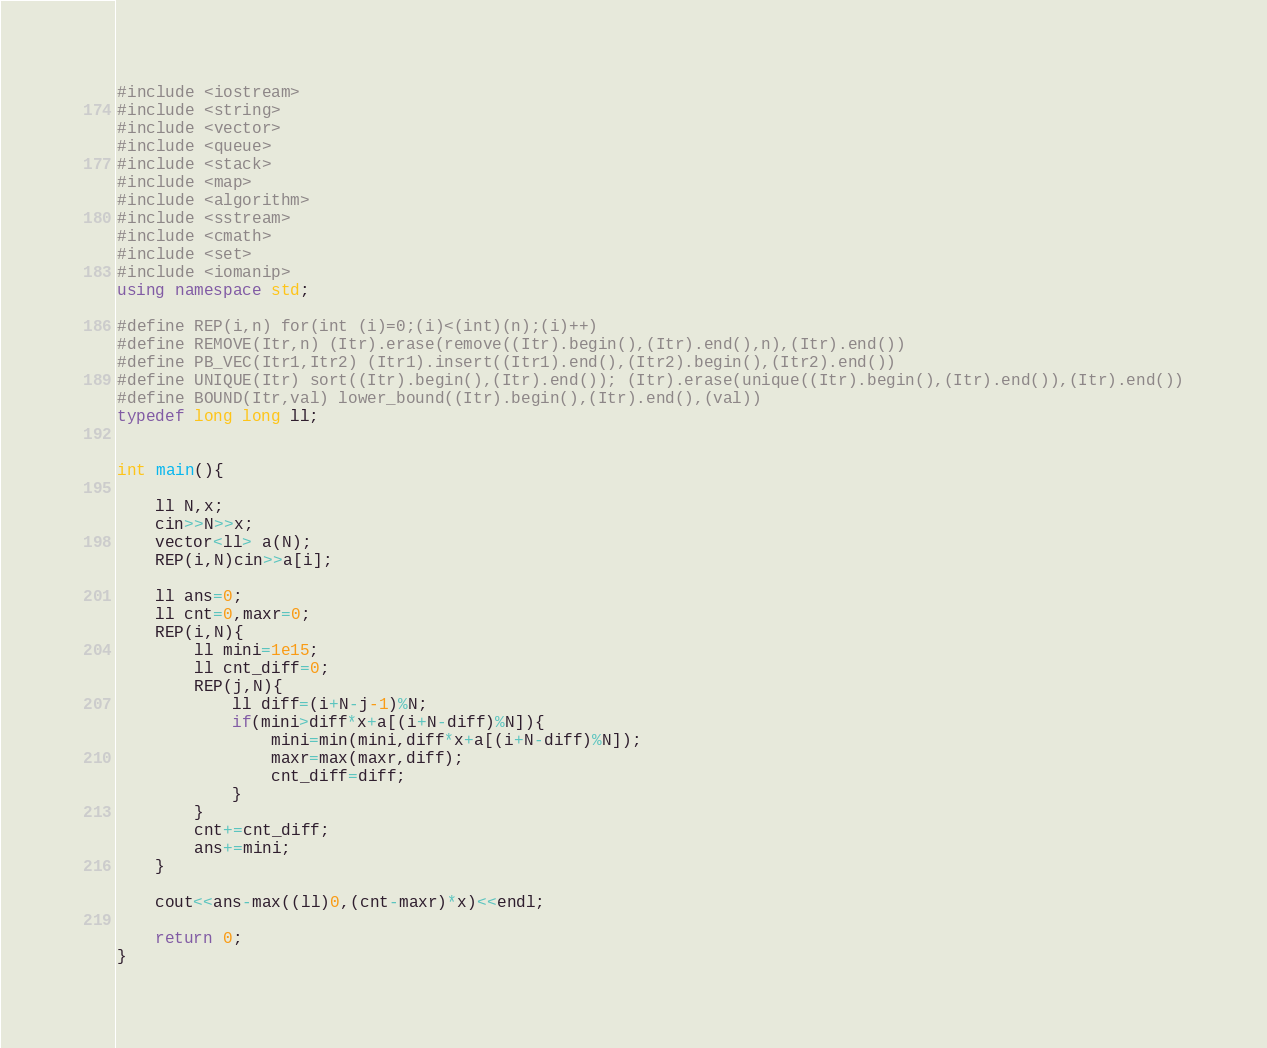Convert code to text. <code><loc_0><loc_0><loc_500><loc_500><_C++_>#include <iostream>
#include <string>
#include <vector>
#include <queue>
#include <stack>
#include <map>
#include <algorithm>
#include <sstream>
#include <cmath>
#include <set>
#include <iomanip>
using namespace std;

#define REP(i,n) for(int (i)=0;(i)<(int)(n);(i)++)
#define REMOVE(Itr,n) (Itr).erase(remove((Itr).begin(),(Itr).end(),n),(Itr).end())
#define PB_VEC(Itr1,Itr2) (Itr1).insert((Itr1).end(),(Itr2).begin(),(Itr2).end())
#define UNIQUE(Itr) sort((Itr).begin(),(Itr).end()); (Itr).erase(unique((Itr).begin(),(Itr).end()),(Itr).end())
#define BOUND(Itr,val) lower_bound((Itr).begin(),(Itr).end(),(val))
typedef long long ll;


int main(){
    
    ll N,x;
    cin>>N>>x;
    vector<ll> a(N);
    REP(i,N)cin>>a[i];
    
    ll ans=0;
    ll cnt=0,maxr=0;
    REP(i,N){
        ll mini=1e15;
        ll cnt_diff=0;
        REP(j,N){
            ll diff=(i+N-j-1)%N;
            if(mini>diff*x+a[(i+N-diff)%N]){
                mini=min(mini,diff*x+a[(i+N-diff)%N]);
                maxr=max(maxr,diff);
                cnt_diff=diff;
            }
        }
        cnt+=cnt_diff;
        ans+=mini;
    }
    
    cout<<ans-max((ll)0,(cnt-maxr)*x)<<endl;
    
    return 0;
}
</code> 